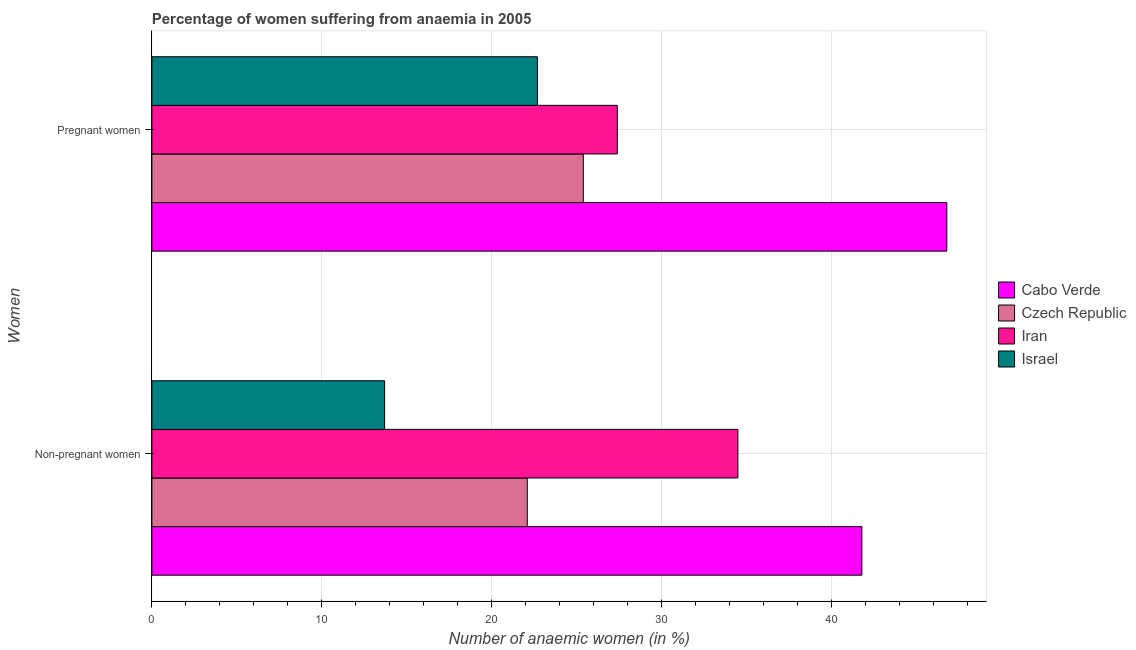How many different coloured bars are there?
Make the answer very short. 4. Are the number of bars per tick equal to the number of legend labels?
Provide a short and direct response. Yes. Are the number of bars on each tick of the Y-axis equal?
Make the answer very short. Yes. What is the label of the 2nd group of bars from the top?
Ensure brevity in your answer.  Non-pregnant women. What is the percentage of non-pregnant anaemic women in Czech Republic?
Your response must be concise. 22.1. Across all countries, what is the maximum percentage of pregnant anaemic women?
Make the answer very short. 46.8. In which country was the percentage of pregnant anaemic women maximum?
Keep it short and to the point. Cabo Verde. What is the total percentage of pregnant anaemic women in the graph?
Provide a succinct answer. 122.3. What is the difference between the percentage of non-pregnant anaemic women in Cabo Verde and that in Israel?
Make the answer very short. 28.1. What is the difference between the percentage of pregnant anaemic women in Czech Republic and the percentage of non-pregnant anaemic women in Iran?
Give a very brief answer. -9.1. What is the average percentage of pregnant anaemic women per country?
Keep it short and to the point. 30.57. What is the difference between the percentage of pregnant anaemic women and percentage of non-pregnant anaemic women in Cabo Verde?
Keep it short and to the point. 5. In how many countries, is the percentage of pregnant anaemic women greater than 18 %?
Your answer should be very brief. 4. What is the ratio of the percentage of non-pregnant anaemic women in Iran to that in Czech Republic?
Your response must be concise. 1.56. What does the 3rd bar from the top in Non-pregnant women represents?
Keep it short and to the point. Czech Republic. What does the 1st bar from the bottom in Pregnant women represents?
Provide a short and direct response. Cabo Verde. How many countries are there in the graph?
Give a very brief answer. 4. Are the values on the major ticks of X-axis written in scientific E-notation?
Provide a short and direct response. No. How are the legend labels stacked?
Ensure brevity in your answer.  Vertical. What is the title of the graph?
Keep it short and to the point. Percentage of women suffering from anaemia in 2005. Does "Small states" appear as one of the legend labels in the graph?
Your answer should be compact. No. What is the label or title of the X-axis?
Your response must be concise. Number of anaemic women (in %). What is the label or title of the Y-axis?
Give a very brief answer. Women. What is the Number of anaemic women (in %) in Cabo Verde in Non-pregnant women?
Your answer should be compact. 41.8. What is the Number of anaemic women (in %) in Czech Republic in Non-pregnant women?
Your answer should be very brief. 22.1. What is the Number of anaemic women (in %) in Iran in Non-pregnant women?
Give a very brief answer. 34.5. What is the Number of anaemic women (in %) in Israel in Non-pregnant women?
Offer a terse response. 13.7. What is the Number of anaemic women (in %) of Cabo Verde in Pregnant women?
Your response must be concise. 46.8. What is the Number of anaemic women (in %) in Czech Republic in Pregnant women?
Provide a short and direct response. 25.4. What is the Number of anaemic women (in %) in Iran in Pregnant women?
Your answer should be very brief. 27.4. What is the Number of anaemic women (in %) of Israel in Pregnant women?
Your response must be concise. 22.7. Across all Women, what is the maximum Number of anaemic women (in %) of Cabo Verde?
Provide a succinct answer. 46.8. Across all Women, what is the maximum Number of anaemic women (in %) in Czech Republic?
Your answer should be compact. 25.4. Across all Women, what is the maximum Number of anaemic women (in %) of Iran?
Make the answer very short. 34.5. Across all Women, what is the maximum Number of anaemic women (in %) in Israel?
Provide a succinct answer. 22.7. Across all Women, what is the minimum Number of anaemic women (in %) of Cabo Verde?
Keep it short and to the point. 41.8. Across all Women, what is the minimum Number of anaemic women (in %) of Czech Republic?
Keep it short and to the point. 22.1. Across all Women, what is the minimum Number of anaemic women (in %) of Iran?
Your response must be concise. 27.4. Across all Women, what is the minimum Number of anaemic women (in %) in Israel?
Your answer should be compact. 13.7. What is the total Number of anaemic women (in %) in Cabo Verde in the graph?
Your answer should be very brief. 88.6. What is the total Number of anaemic women (in %) of Czech Republic in the graph?
Offer a very short reply. 47.5. What is the total Number of anaemic women (in %) of Iran in the graph?
Ensure brevity in your answer.  61.9. What is the total Number of anaemic women (in %) of Israel in the graph?
Offer a terse response. 36.4. What is the difference between the Number of anaemic women (in %) of Iran in Non-pregnant women and that in Pregnant women?
Provide a short and direct response. 7.1. What is the difference between the Number of anaemic women (in %) of Czech Republic in Non-pregnant women and the Number of anaemic women (in %) of Israel in Pregnant women?
Provide a succinct answer. -0.6. What is the difference between the Number of anaemic women (in %) in Iran in Non-pregnant women and the Number of anaemic women (in %) in Israel in Pregnant women?
Offer a very short reply. 11.8. What is the average Number of anaemic women (in %) in Cabo Verde per Women?
Your answer should be compact. 44.3. What is the average Number of anaemic women (in %) of Czech Republic per Women?
Your answer should be very brief. 23.75. What is the average Number of anaemic women (in %) in Iran per Women?
Keep it short and to the point. 30.95. What is the average Number of anaemic women (in %) of Israel per Women?
Your response must be concise. 18.2. What is the difference between the Number of anaemic women (in %) of Cabo Verde and Number of anaemic women (in %) of Iran in Non-pregnant women?
Make the answer very short. 7.3. What is the difference between the Number of anaemic women (in %) of Cabo Verde and Number of anaemic women (in %) of Israel in Non-pregnant women?
Keep it short and to the point. 28.1. What is the difference between the Number of anaemic women (in %) of Czech Republic and Number of anaemic women (in %) of Israel in Non-pregnant women?
Keep it short and to the point. 8.4. What is the difference between the Number of anaemic women (in %) of Iran and Number of anaemic women (in %) of Israel in Non-pregnant women?
Your response must be concise. 20.8. What is the difference between the Number of anaemic women (in %) in Cabo Verde and Number of anaemic women (in %) in Czech Republic in Pregnant women?
Offer a terse response. 21.4. What is the difference between the Number of anaemic women (in %) in Cabo Verde and Number of anaemic women (in %) in Israel in Pregnant women?
Keep it short and to the point. 24.1. What is the difference between the Number of anaemic women (in %) in Czech Republic and Number of anaemic women (in %) in Iran in Pregnant women?
Offer a terse response. -2. What is the ratio of the Number of anaemic women (in %) of Cabo Verde in Non-pregnant women to that in Pregnant women?
Give a very brief answer. 0.89. What is the ratio of the Number of anaemic women (in %) of Czech Republic in Non-pregnant women to that in Pregnant women?
Your answer should be compact. 0.87. What is the ratio of the Number of anaemic women (in %) in Iran in Non-pregnant women to that in Pregnant women?
Give a very brief answer. 1.26. What is the ratio of the Number of anaemic women (in %) in Israel in Non-pregnant women to that in Pregnant women?
Ensure brevity in your answer.  0.6. What is the difference between the highest and the second highest Number of anaemic women (in %) in Cabo Verde?
Provide a succinct answer. 5. What is the difference between the highest and the second highest Number of anaemic women (in %) in Czech Republic?
Offer a very short reply. 3.3. What is the difference between the highest and the second highest Number of anaemic women (in %) in Iran?
Keep it short and to the point. 7.1. What is the difference between the highest and the lowest Number of anaemic women (in %) in Czech Republic?
Offer a terse response. 3.3. What is the difference between the highest and the lowest Number of anaemic women (in %) of Iran?
Your answer should be compact. 7.1. 